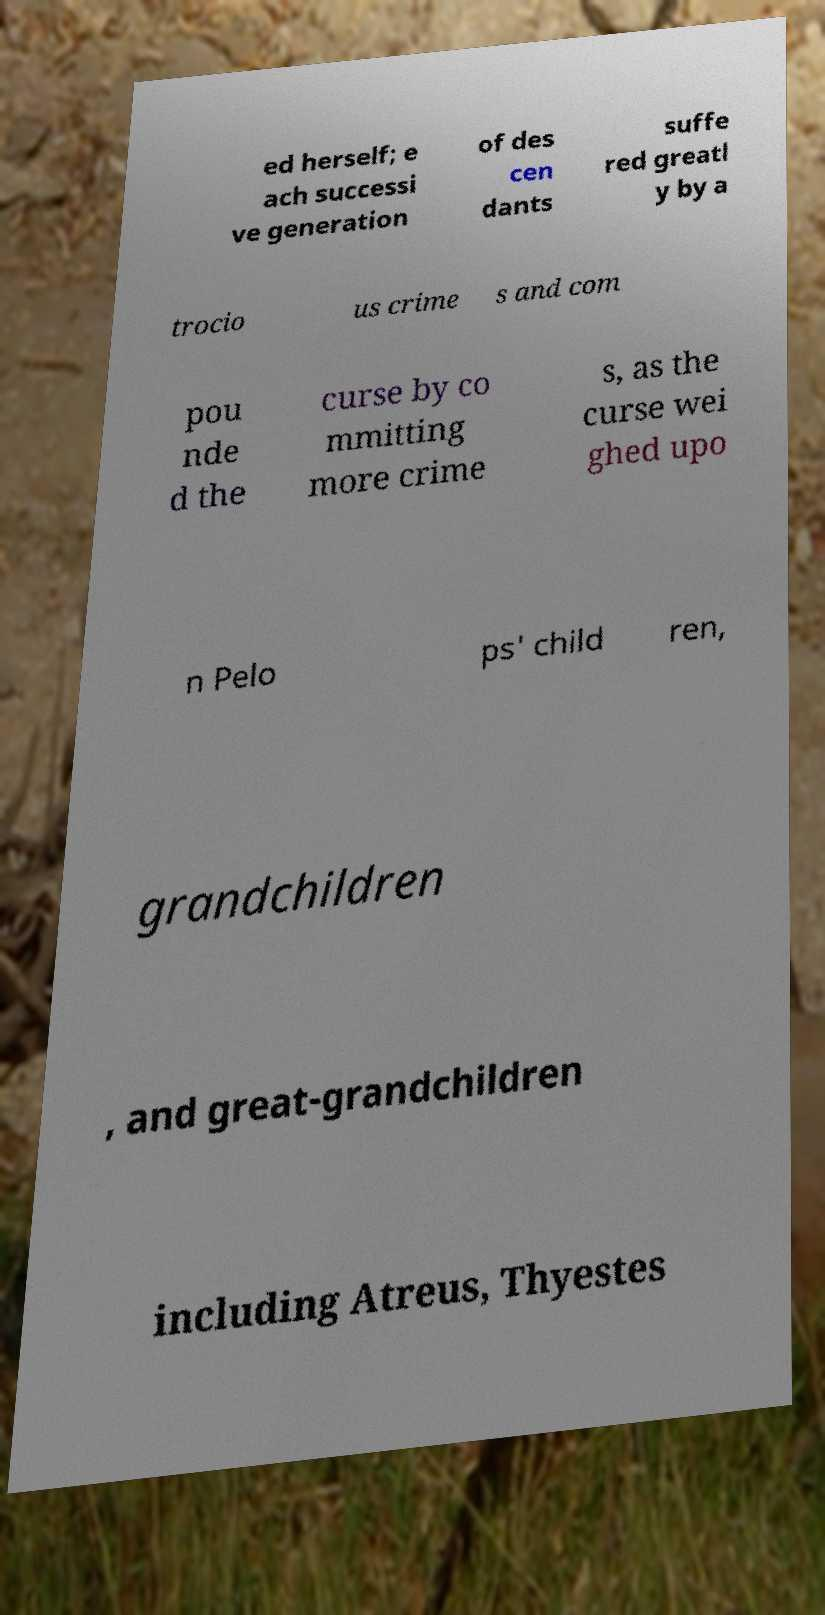Please identify and transcribe the text found in this image. ed herself; e ach successi ve generation of des cen dants suffe red greatl y by a trocio us crime s and com pou nde d the curse by co mmitting more crime s, as the curse wei ghed upo n Pelo ps' child ren, grandchildren , and great-grandchildren including Atreus, Thyestes 